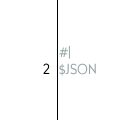<code> <loc_0><loc_0><loc_500><loc_500><_Scheme_>#|
$JSON</code> 